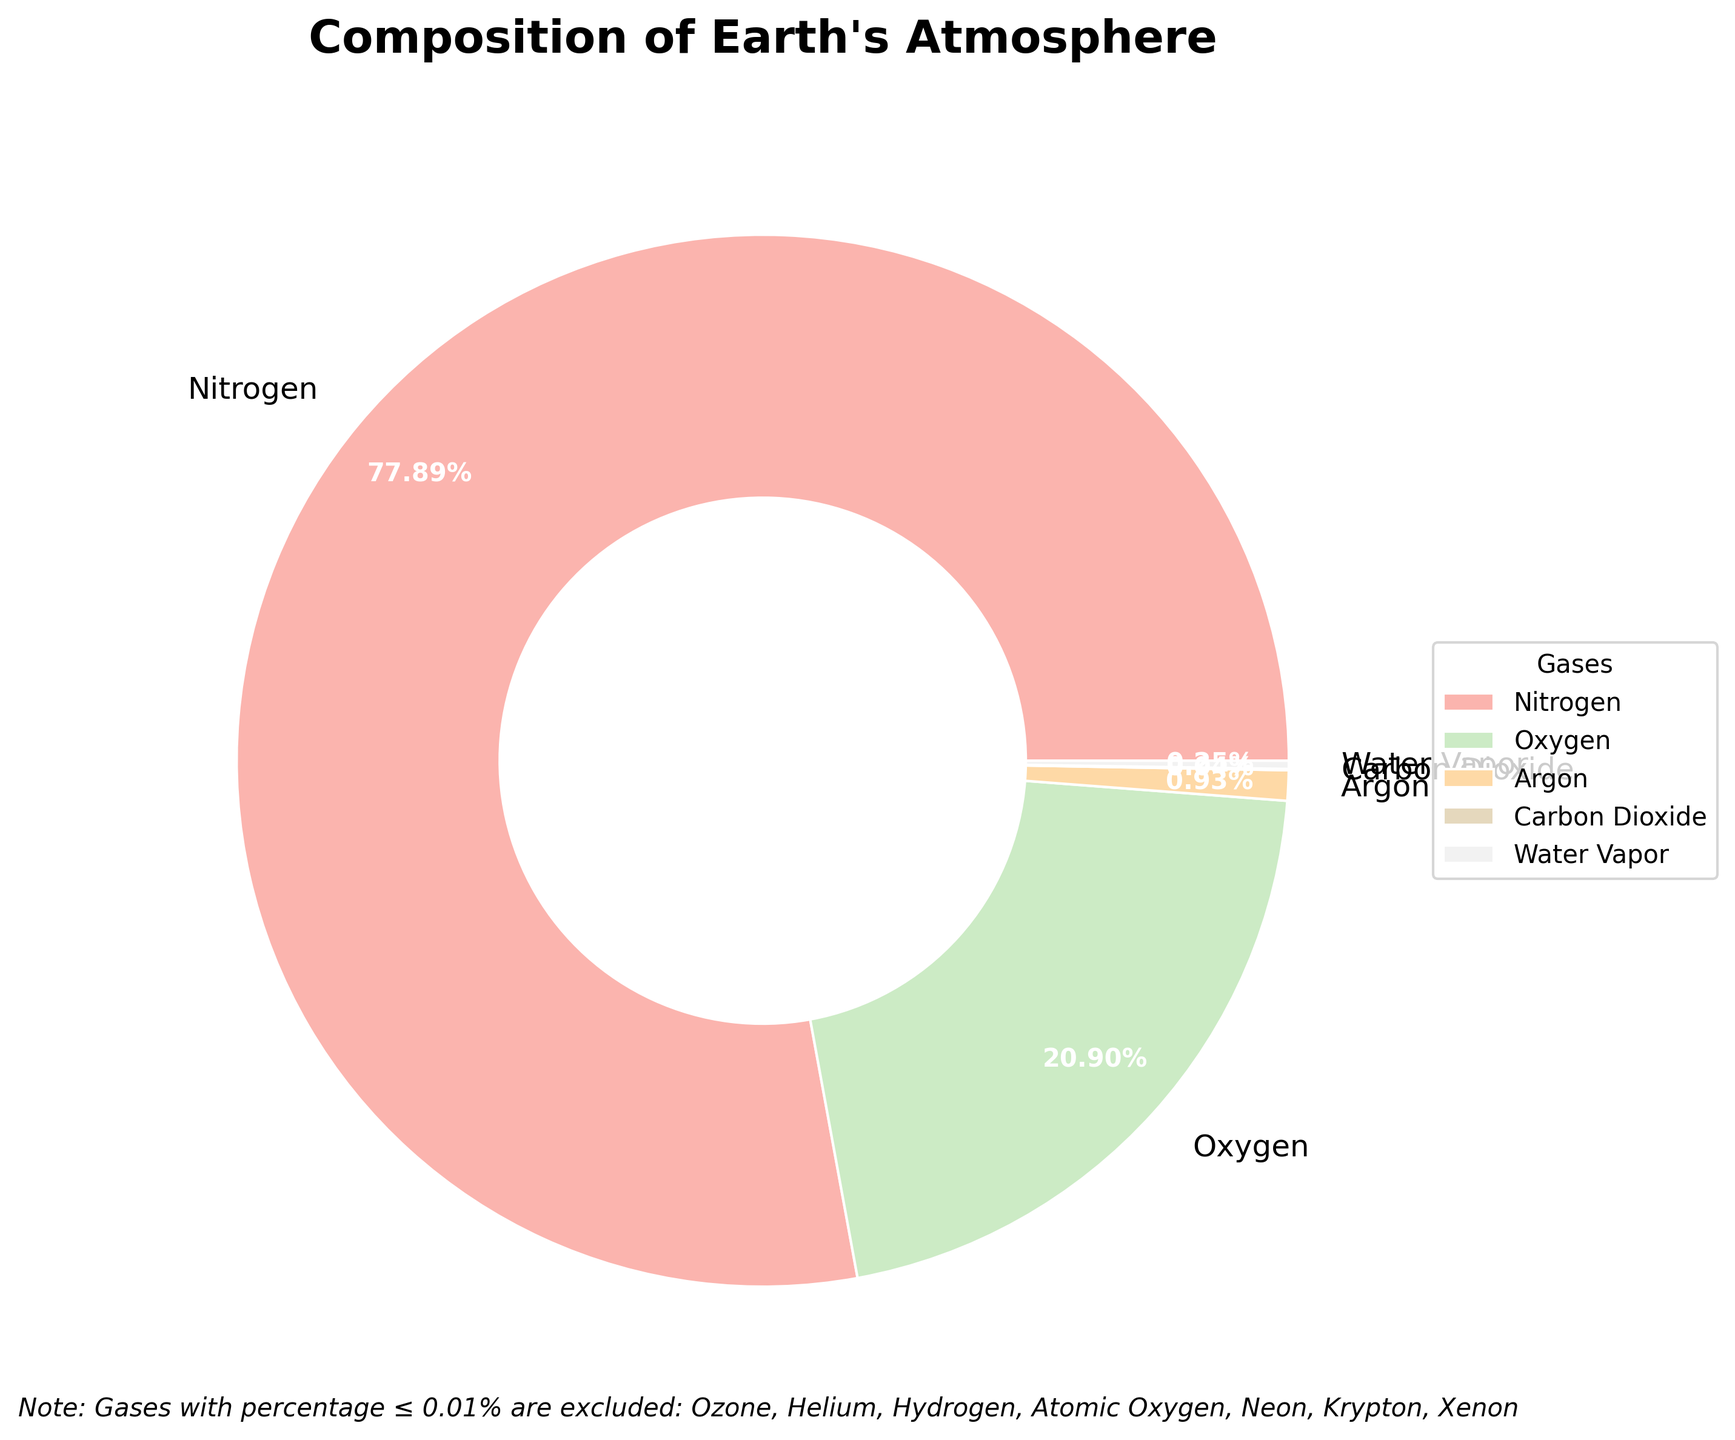What's the largest gas component in the Troposphere? By looking at the pie chart, identify the gas associated with the largest wedge in the Troposphere section of the pie. It is likely labeled and visually the largest section.
Answer: Nitrogen Which gases are excluded from the main visualization due to their small percentages? Locate the note at the bottom of the pie chart that lists gases excluded from the main visualization. This note provides a list of gases with percentages ≤ 0.01%.
Answer: Ozone, Helium, Hydrogen, Atomic Oxygen, Neon, Krypton, Xenon What is the combined percentage of Nitrogen and Oxygen in the Troposphere? Find the percentage values for Nitrogen and Oxygen in the Troposphere section, then sum these values: 78.08% (Nitrogen) + 20.95% (Oxygen) = 99.03%.
Answer: 99.03% Which gas is represented with the smallest wedge in the filtered data? Observe the filtered wedges in the pie chart and identify the gas corresponding to the smallest wedge.
Answer: Carbon Dioxide How does the portion of Argon compare to the combined portion of Water Vapor and Carbon Dioxide in the Troposphere? Locate the percentages for Argon, Water Vapor, and Carbon Dioxide in the Troposphere. Argon is 0.93%, Water Vapor is 0.25%, and Carbon Dioxide is 0.04%. Sum up Water Vapor and Carbon Dioxide: 0.25% + 0.04% = 0.29%. Compare this total to Argon’s percentage: 0.93% > 0.29%.
Answer: Argon is larger Which section of the pie chart has the brightest color, and which gas does it represent? Look at the chart and identify the section with the visually brightest color. Observe its label to determine the corresponding gas.
Answer: Oxygen How much greater is the percentage of Nitrogen compared to Argon in the Troposphere? Subtract the percentage of Argon from the percentage of Nitrogen in the Troposphere. Nitrogen is 78.08% and Argon is 0.93%. The difference is 78.08% - 0.93% = 77.15%.
Answer: 77.15% What gas has a percentage of 0.25% and where is it located? Identify the wedge labeled with “0.25%” and look at the corresponding label for the gas name. Also, note which layer this gas is found in.
Answer: Water Vapor, Troposphere 